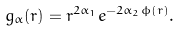<formula> <loc_0><loc_0><loc_500><loc_500>g _ { \alpha } ( r ) = r ^ { 2 \alpha _ { 1 } } e ^ { - 2 \alpha _ { 2 } \phi ( r ) } .</formula> 